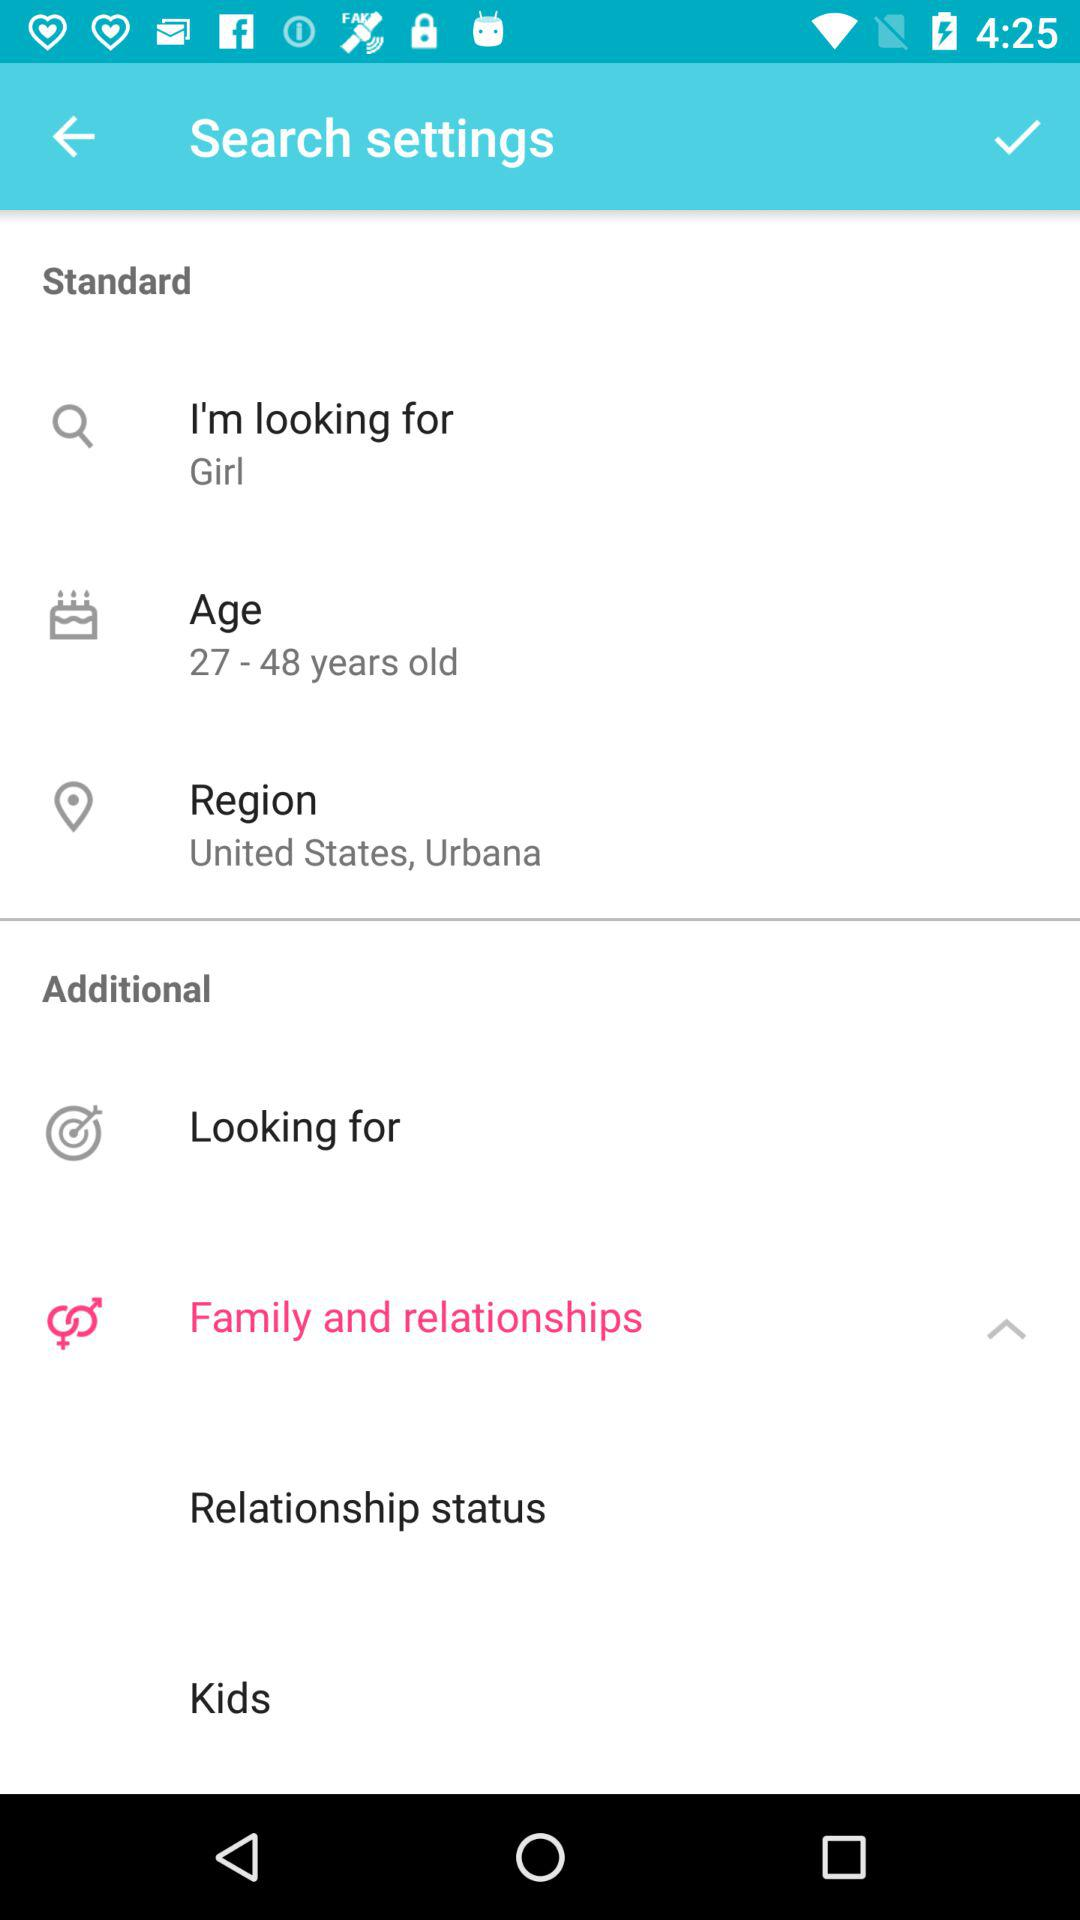What is the selected option? The selected option is "Family and relationships". 